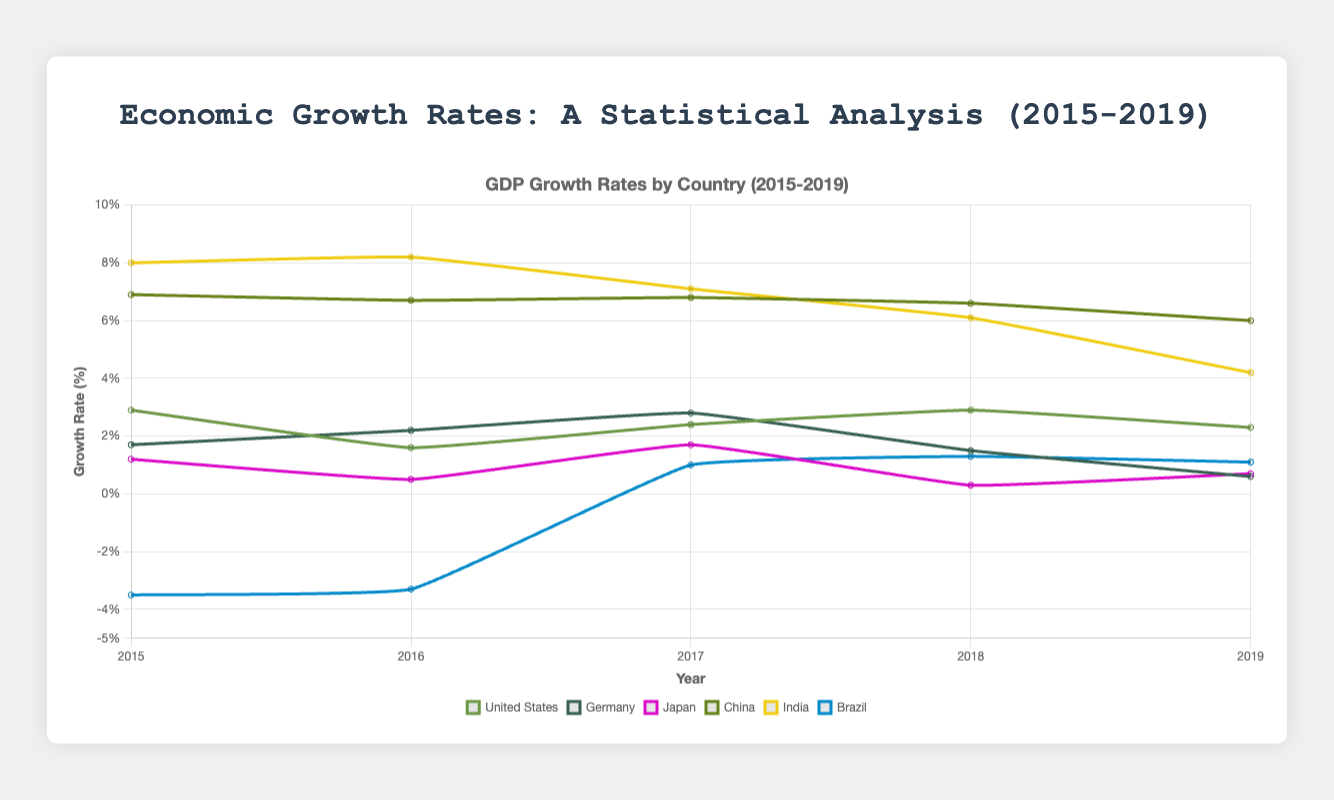What is the average GDP growth rate of the United States from 2015 to 2019? Sum up the growth rates of the United States from 2015 to 2019: 2.9 + 1.6 + 2.4 + 2.9 + 2.3 = 12.1. Then divide by the number of years (5): 12.1 / 5 = 2.42.
Answer: 2.42% Which country had the highest GDP growth rate in any single year between 2015 and 2019? Look at all the growth rates and identify the highest value, which is 8.2%. India had this growth rate in 2016.
Answer: India How did China's GDP growth rate change over the years from 2015 to 2019? Observe the trend in China's growth rates from the plot: 6.9%, 6.7%, 6.8%, 6.6%, and 6.0%. It initially decreased slightly, increased a bit in 2017, and then continuously decreased till 2019.
Answer: Decreasing trend with a slight increase in 2017 Compare the GDP growth rate of Brazil in 2016 and 2019. How much did it change? Check Brazil's growth rates for 2016 and 2019: -3.3% and 1.1%. To find the change: 1.1 - (-3.3) = 1.1 + 3.3 = 4.4%.
Answer: 4.4% Which country experienced a negative GDP growth rate across the years shown and what is the trend? Identify the country with negative growth rates: Brazil had negative growth rates in 2015 and 2016. The trend shows an increase from -3.5% in 2015 to more positive values in the following years.
Answer: Brazil, increasing trend after 2016 What visual pattern can you observe in India's GDP growth rates from 2015 to 2019? Look at the pattern formed by India's growth rates: 8.0%, 8.2%, 7.1%, 6.1%, 4.2%. It shows a high peak in 2016 followed by a continuous decline.
Answer: Declining trend after a peak in 2016 